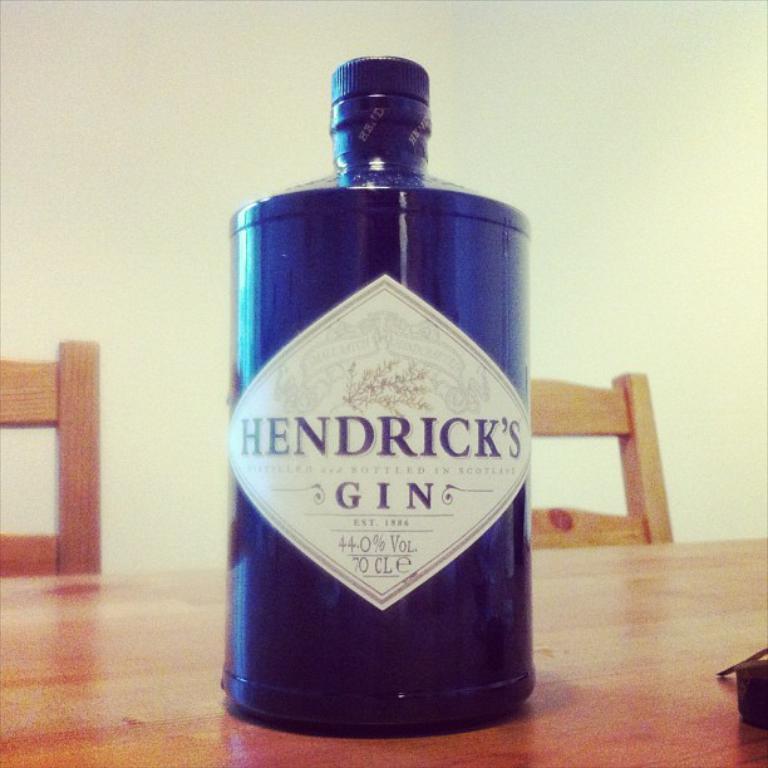What brand of gin is this?
Make the answer very short. Hendrick's. 